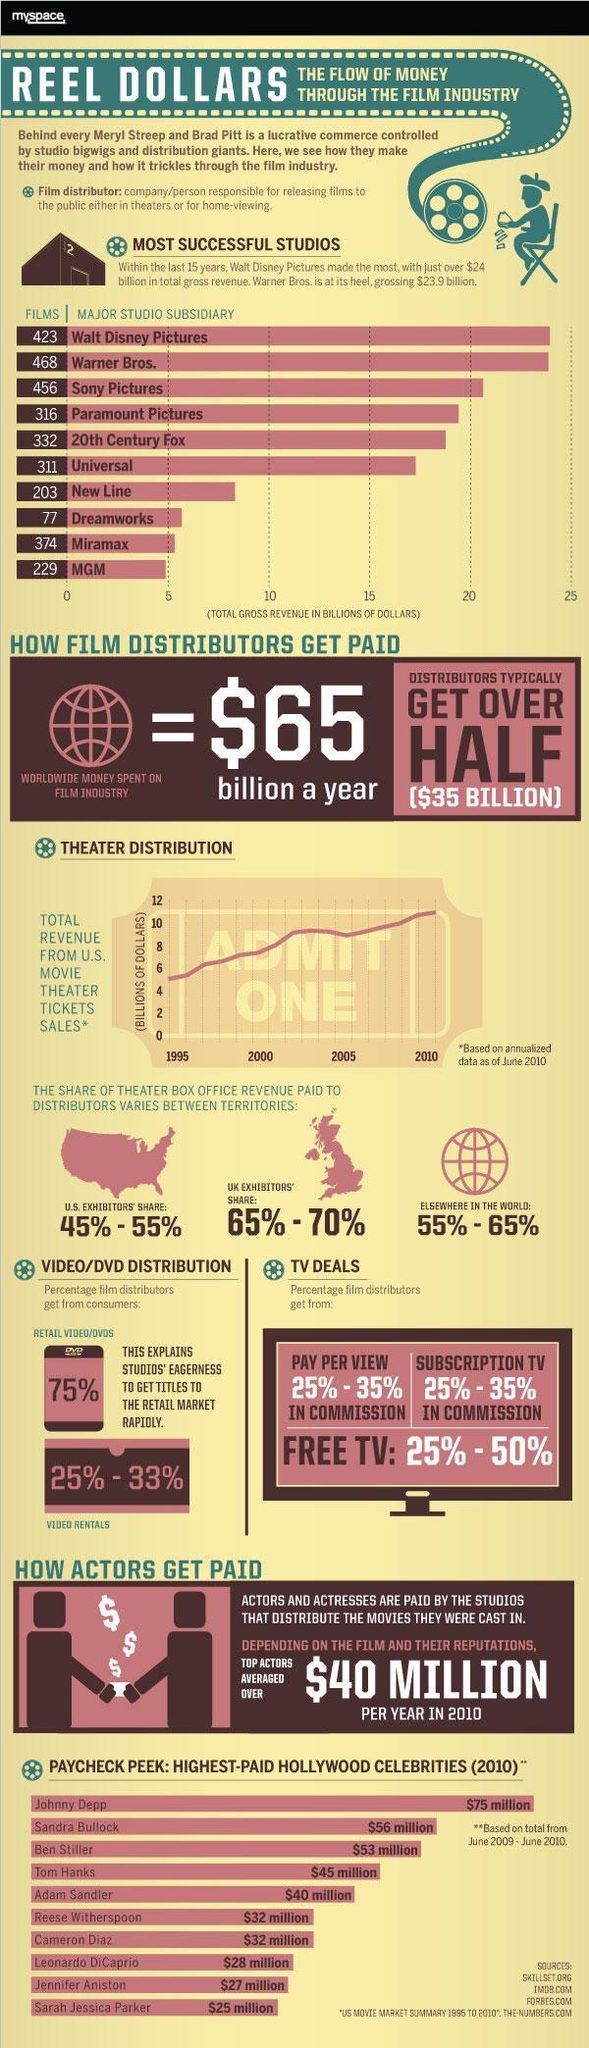what was the total revenue from US movie ticket sales in 1995 in billion dollars?
Answer the question with a short phrase. 5 what is the maximum percentage film distributers get from free TV? 50% what was the total revenue from US movie ticket sales in 2001 in billion dollars? 8 who is the second most paid celebrity of Hollywood in 2010? Sandra Bullock How many studios have achieved more than 15 billion dollars gross revenue? 6 what was the total revenue from US movie ticket sales in 1999 in billion dollars? 7 what is the total number of films made by top 5 successful studios in Hollywood? 1995 What is the pay gap in million dollars between the highest paid and second highest paid celebrities of Hollywood in 2010? 19 who is the total amount paid to the highest paid celebrity of Hollywood in 2010? $75 million what is the maximum percentage film distributers get from subscription TV in commission? 35% 